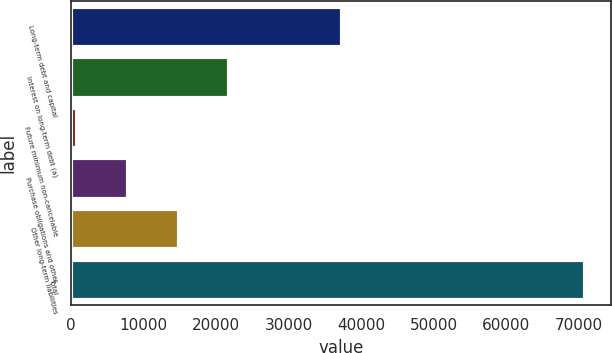<chart> <loc_0><loc_0><loc_500><loc_500><bar_chart><fcel>Long-term debt and capital<fcel>Interest on long-term debt (a)<fcel>Future minimum non-cancelable<fcel>Purchase obligations and other<fcel>Other long-term liabilities<fcel>Total<nl><fcel>37360<fcel>21839<fcel>809<fcel>7819<fcel>14829<fcel>70909<nl></chart> 